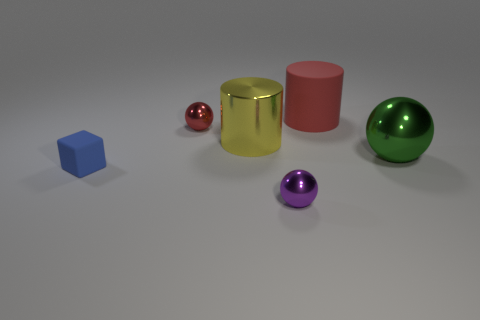Subtract all small metallic balls. How many balls are left? 1 Subtract all cubes. How many objects are left? 5 Add 1 purple rubber cylinders. How many objects exist? 7 Subtract 1 balls. How many balls are left? 2 Subtract all yellow cylinders. How many cylinders are left? 1 Add 2 big yellow metallic things. How many big yellow metallic things exist? 3 Subtract 0 green cylinders. How many objects are left? 6 Subtract all gray blocks. Subtract all cyan cylinders. How many blocks are left? 1 Subtract all yellow spheres. How many red cylinders are left? 1 Subtract all big yellow shiny cylinders. Subtract all red matte cylinders. How many objects are left? 4 